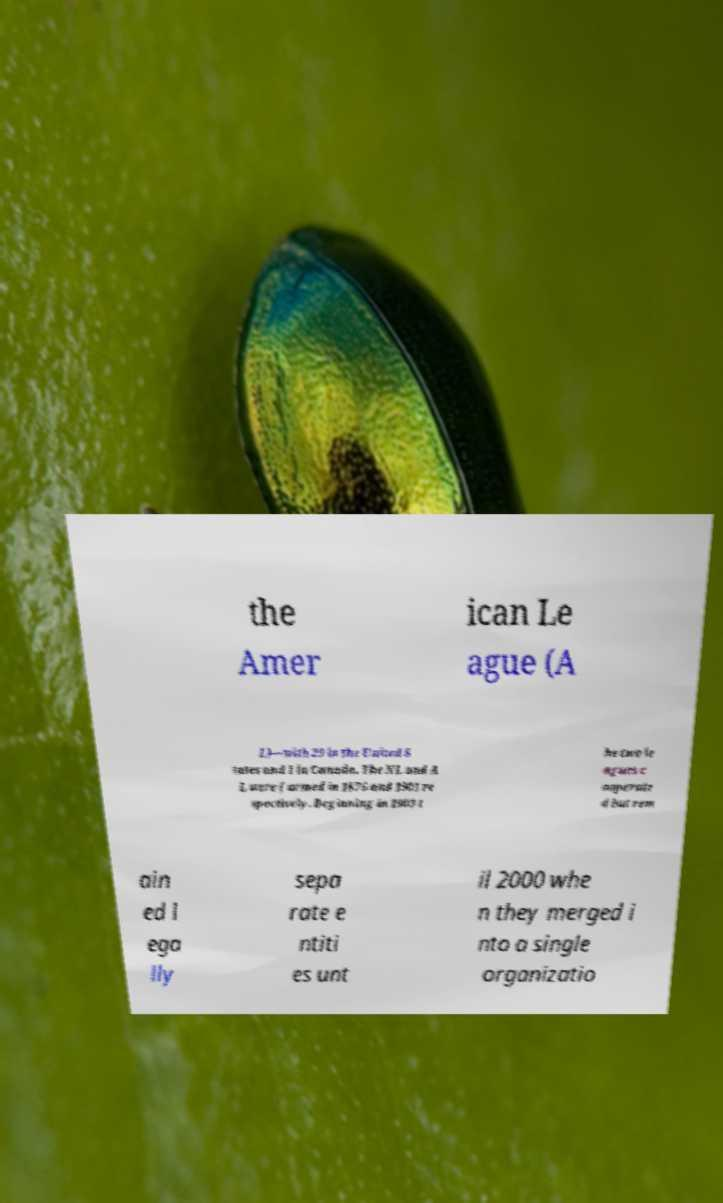There's text embedded in this image that I need extracted. Can you transcribe it verbatim? the Amer ican Le ague (A L)—with 29 in the United S tates and 1 in Canada. The NL and A L were formed in 1876 and 1901 re spectively. Beginning in 1903 t he two le agues c ooperate d but rem ain ed l ega lly sepa rate e ntiti es unt il 2000 whe n they merged i nto a single organizatio 